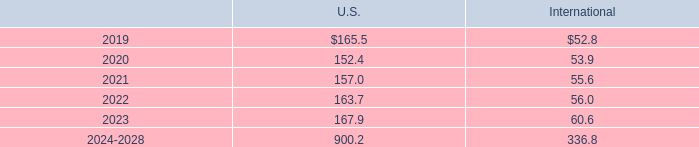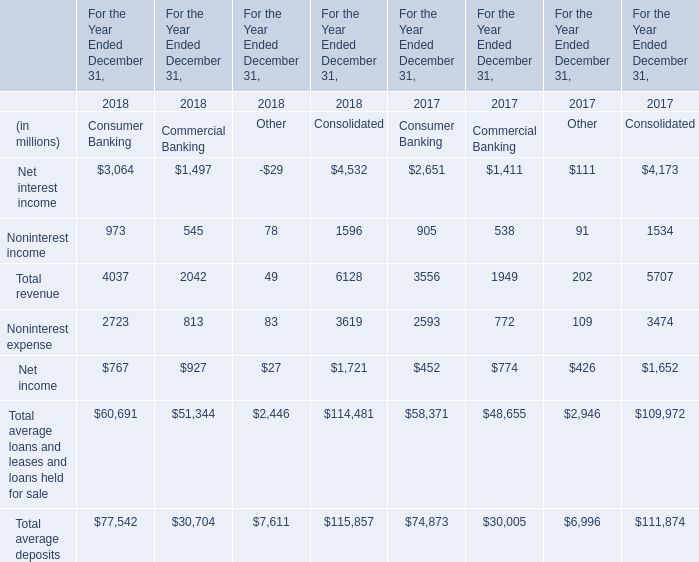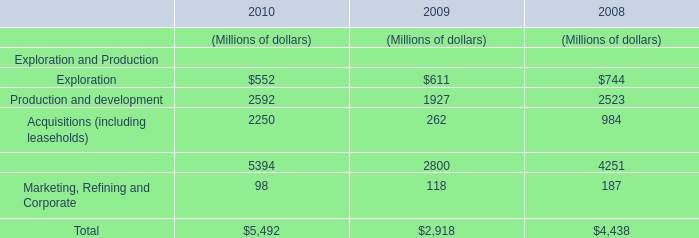What is the sum of Noninterest income of Consumer Banking in 2018 and Production and development in 2009? (in million) 
Computations: (973 + 1927)
Answer: 2900.0. 